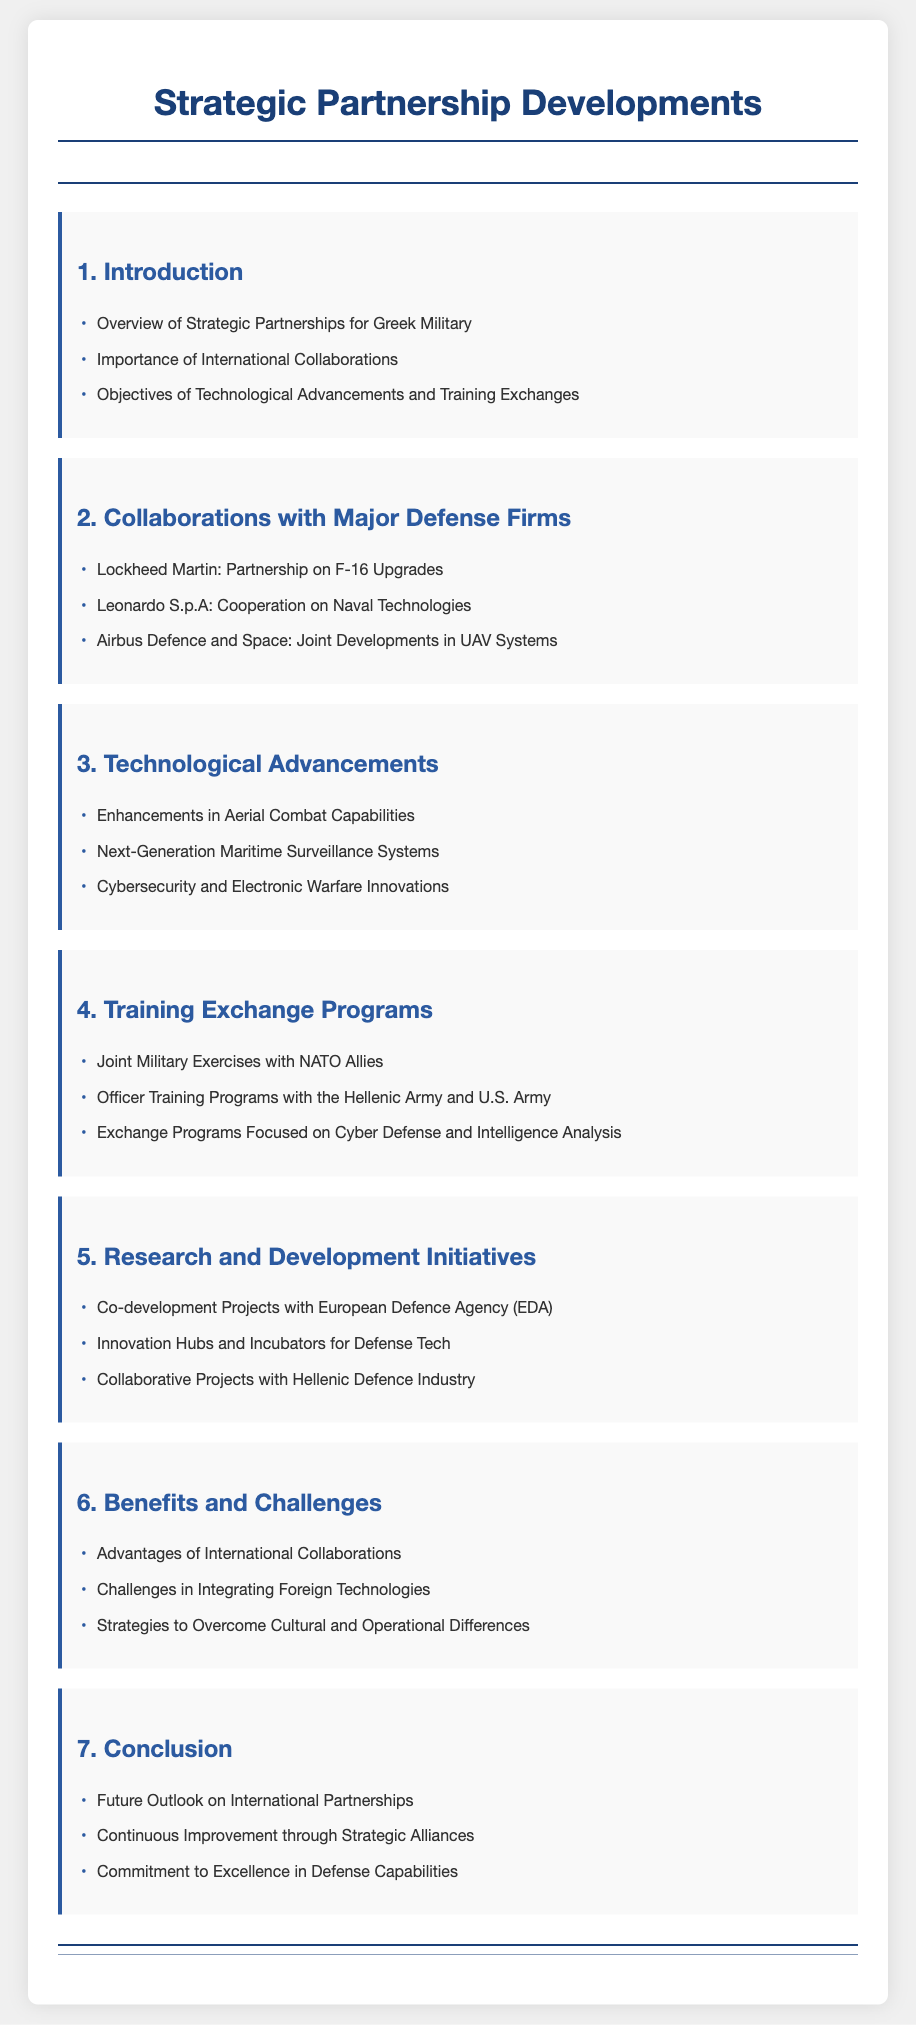what is the title of the document? The title of the document is prominently displayed at the top of the rendered page.
Answer: Strategic Partnership Developments how many collaborations with major defense firms are listed? The section lists three specific collaborations with major defense firms.
Answer: 3 which firm is involved in partnership on F-16 upgrades? This detail is given in the section about collaborations with major defense firms.
Answer: Lockheed Martin what type of capabilities are being enhanced? The document mentions a specific area focused on technological advancements.
Answer: Aerial Combat Capabilities what is one focus of the training exchange programs? This information is found in the training exchange programs section, highlighting key areas of training.
Answer: Cyber Defense who is involved in officer training programs? This detail involves multiple military branches highlighted in the document.
Answer: Hellenic Army and U.S. Army what is the benefit of international collaborations? This is mentioned in the benefits and challenges section of the document.
Answer: Advantages what initiative is mentioned for research and development? The document outlines specific projects and initiatives in the R&D section.
Answer: Co-development Projects with European Defence Agency (EDA) which technological area involves cybersecurity? This information is categorized under technological advancements in the document.
Answer: Electronic Warfare Innovations 